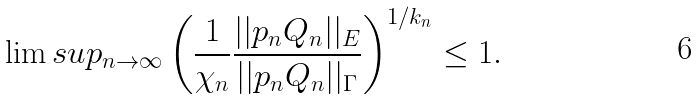Convert formula to latex. <formula><loc_0><loc_0><loc_500><loc_500>\lim s u p _ { n \to \infty } \left ( \frac { 1 } { \chi _ { n } } \frac { | | p _ { n } Q _ { n } | | _ { E } } { | | p _ { n } Q _ { n } | | _ { \Gamma } } \right ) ^ { 1 / k _ { n } } \leq 1 .</formula> 